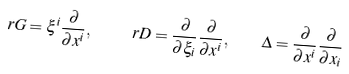<formula> <loc_0><loc_0><loc_500><loc_500>\ r G = \xi ^ { i } \frac { \partial } { \partial x ^ { i } } , \quad \ r D = \frac { \partial } { \partial \xi _ { i } } \frac { \partial } { \partial x ^ { i } } , \quad \Delta = \frac { \partial } { \partial x ^ { i } } \frac { \partial } { \partial x _ { i } }</formula> 